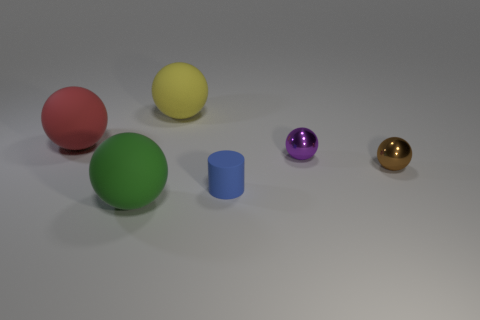What is the shape of the small object that is left of the purple metal object that is right of the large green rubber ball in front of the tiny rubber thing?
Make the answer very short. Cylinder. There is a ball in front of the tiny blue matte cylinder; what color is it?
Provide a succinct answer. Green. What number of objects are large spheres that are to the right of the big red rubber sphere or spheres left of the tiny matte object?
Your response must be concise. 3. What number of other big objects are the same shape as the large yellow thing?
Your answer should be compact. 2. The other shiny ball that is the same size as the brown sphere is what color?
Your response must be concise. Purple. What color is the large rubber sphere that is right of the matte ball in front of the big sphere that is to the left of the green matte ball?
Your response must be concise. Yellow. There is a red matte ball; does it have the same size as the shiny sphere in front of the purple sphere?
Your response must be concise. No. How many things are either matte balls or tiny yellow things?
Give a very brief answer. 3. Are there any purple balls made of the same material as the tiny brown thing?
Offer a very short reply. Yes. What is the color of the sphere on the right side of the metal sphere that is behind the tiny brown sphere?
Ensure brevity in your answer.  Brown. 